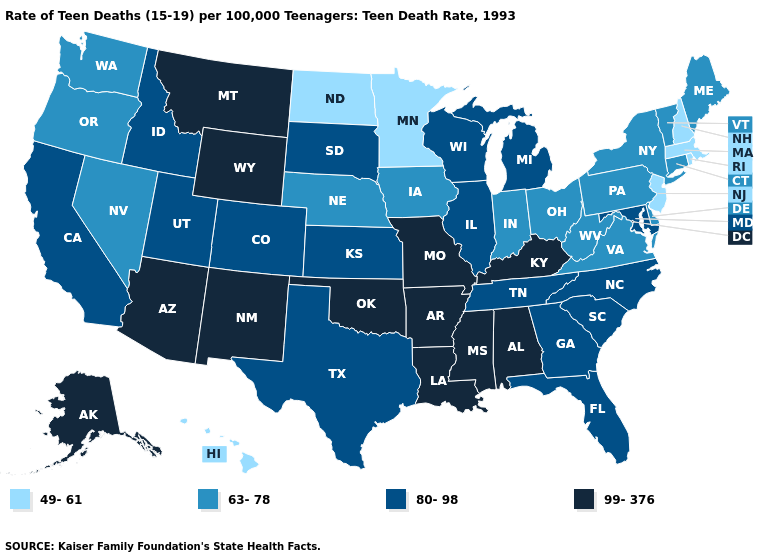Does Missouri have the highest value in the MidWest?
Concise answer only. Yes. Among the states that border Kentucky , does Indiana have the highest value?
Be succinct. No. Does New Jersey have the lowest value in the USA?
Be succinct. Yes. What is the highest value in the West ?
Quick response, please. 99-376. Name the states that have a value in the range 49-61?
Keep it brief. Hawaii, Massachusetts, Minnesota, New Hampshire, New Jersey, North Dakota, Rhode Island. What is the value of Montana?
Keep it brief. 99-376. What is the lowest value in the USA?
Give a very brief answer. 49-61. Which states have the highest value in the USA?
Answer briefly. Alabama, Alaska, Arizona, Arkansas, Kentucky, Louisiana, Mississippi, Missouri, Montana, New Mexico, Oklahoma, Wyoming. Name the states that have a value in the range 49-61?
Concise answer only. Hawaii, Massachusetts, Minnesota, New Hampshire, New Jersey, North Dakota, Rhode Island. Does Pennsylvania have the lowest value in the Northeast?
Keep it brief. No. Does Hawaii have a higher value than Massachusetts?
Keep it brief. No. Does New York have the lowest value in the USA?
Write a very short answer. No. Which states have the lowest value in the South?
Be succinct. Delaware, Virginia, West Virginia. Among the states that border North Carolina , which have the highest value?
Write a very short answer. Georgia, South Carolina, Tennessee. What is the lowest value in the MidWest?
Answer briefly. 49-61. 